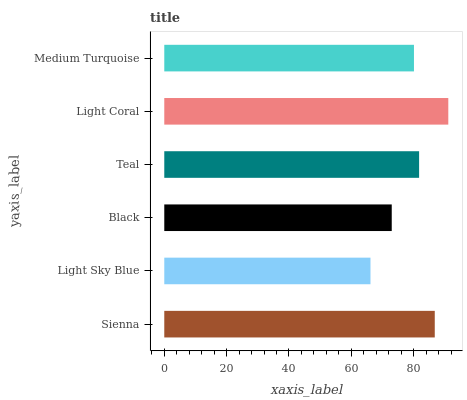Is Light Sky Blue the minimum?
Answer yes or no. Yes. Is Light Coral the maximum?
Answer yes or no. Yes. Is Black the minimum?
Answer yes or no. No. Is Black the maximum?
Answer yes or no. No. Is Black greater than Light Sky Blue?
Answer yes or no. Yes. Is Light Sky Blue less than Black?
Answer yes or no. Yes. Is Light Sky Blue greater than Black?
Answer yes or no. No. Is Black less than Light Sky Blue?
Answer yes or no. No. Is Teal the high median?
Answer yes or no. Yes. Is Medium Turquoise the low median?
Answer yes or no. Yes. Is Light Sky Blue the high median?
Answer yes or no. No. Is Teal the low median?
Answer yes or no. No. 